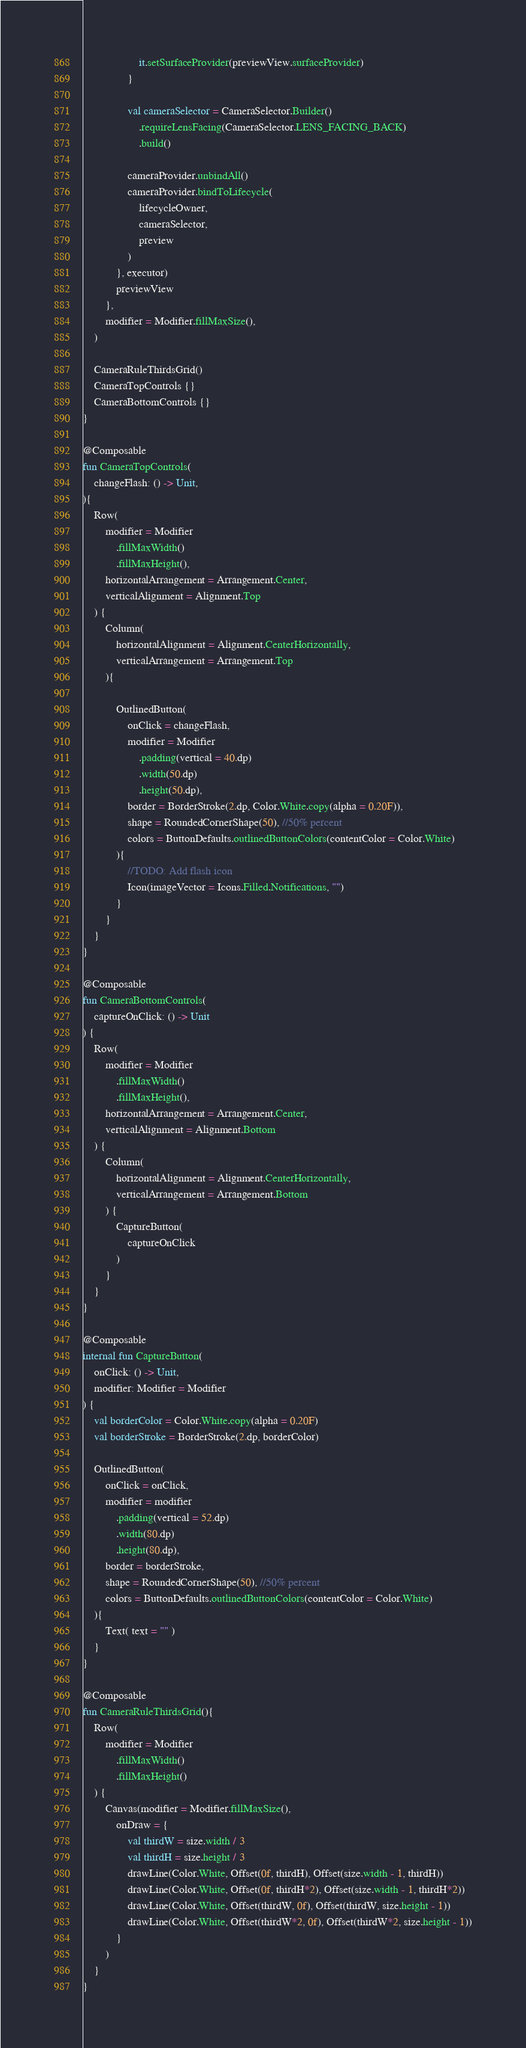Convert code to text. <code><loc_0><loc_0><loc_500><loc_500><_Kotlin_>                    it.setSurfaceProvider(previewView.surfaceProvider)
                }

                val cameraSelector = CameraSelector.Builder()
                    .requireLensFacing(CameraSelector.LENS_FACING_BACK)
                    .build()

                cameraProvider.unbindAll()
                cameraProvider.bindToLifecycle(
                    lifecycleOwner,
                    cameraSelector,
                    preview
                )
            }, executor)
            previewView
        },
        modifier = Modifier.fillMaxSize(),
    )

    CameraRuleThirdsGrid()
    CameraTopControls {}
    CameraBottomControls {}
}

@Composable
fun CameraTopControls(
    changeFlash: () -> Unit,
){
    Row(
        modifier = Modifier
            .fillMaxWidth()
            .fillMaxHeight(),
        horizontalArrangement = Arrangement.Center,
        verticalAlignment = Alignment.Top
    ) {
        Column(
            horizontalAlignment = Alignment.CenterHorizontally,
            verticalArrangement = Arrangement.Top
        ){

            OutlinedButton(
                onClick = changeFlash,
                modifier = Modifier
                    .padding(vertical = 40.dp)
                    .width(50.dp)
                    .height(50.dp),
                border = BorderStroke(2.dp, Color.White.copy(alpha = 0.20F)),
                shape = RoundedCornerShape(50), //50% percent
                colors = ButtonDefaults.outlinedButtonColors(contentColor = Color.White)
            ){
                //TODO: Add flash icon
                Icon(imageVector = Icons.Filled.Notifications, "")
            }
        }
    }
}

@Composable
fun CameraBottomControls(
    captureOnClick: () -> Unit
) {
    Row(
        modifier = Modifier
            .fillMaxWidth()
            .fillMaxHeight(),
        horizontalArrangement = Arrangement.Center,
        verticalAlignment = Alignment.Bottom
    ) {
        Column(
            horizontalAlignment = Alignment.CenterHorizontally,
            verticalArrangement = Arrangement.Bottom
        ) {
            CaptureButton(
                captureOnClick
            )
        }
    }
}

@Composable
internal fun CaptureButton(
    onClick: () -> Unit,
    modifier: Modifier = Modifier
) {
    val borderColor = Color.White.copy(alpha = 0.20F)
    val borderStroke = BorderStroke(2.dp, borderColor)

    OutlinedButton(
        onClick = onClick,
        modifier = modifier
            .padding(vertical = 52.dp)
            .width(80.dp)
            .height(80.dp),
        border = borderStroke,
        shape = RoundedCornerShape(50), //50% percent
        colors = ButtonDefaults.outlinedButtonColors(contentColor = Color.White)
    ){
        Text( text = "" )
    }
}

@Composable
fun CameraRuleThirdsGrid(){
    Row(
        modifier = Modifier
            .fillMaxWidth()
            .fillMaxHeight()
    ) {
        Canvas(modifier = Modifier.fillMaxSize(),
            onDraw = {
                val thirdW = size.width / 3
                val thirdH = size.height / 3
                drawLine(Color.White, Offset(0f, thirdH), Offset(size.width - 1, thirdH))
                drawLine(Color.White, Offset(0f, thirdH*2), Offset(size.width - 1, thirdH*2))
                drawLine(Color.White, Offset(thirdW, 0f), Offset(thirdW, size.height - 1))
                drawLine(Color.White, Offset(thirdW*2, 0f), Offset(thirdW*2, size.height - 1))
            }
        )
    }
}</code> 